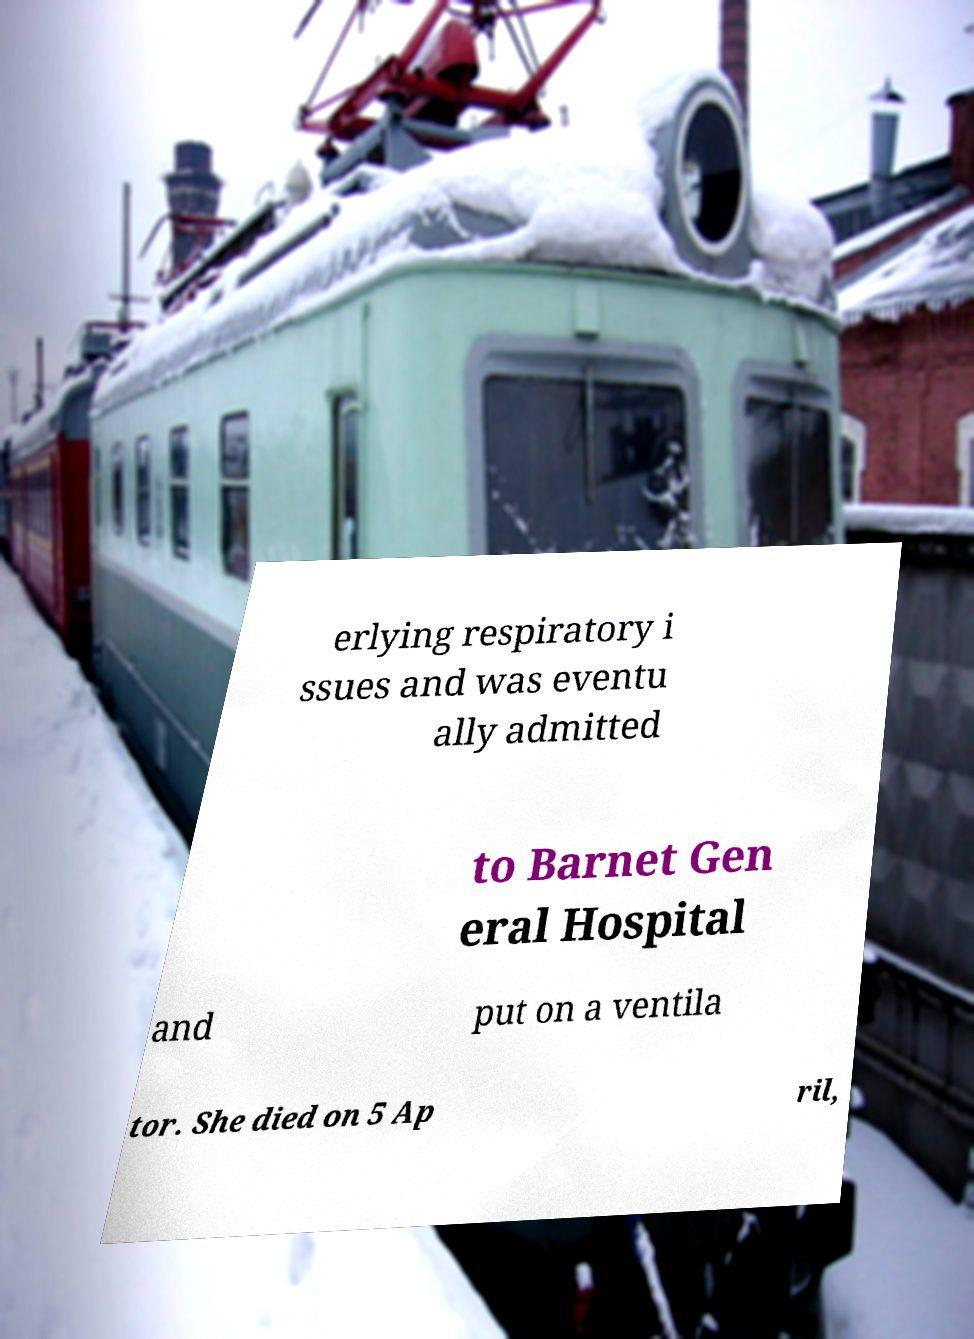Can you read and provide the text displayed in the image?This photo seems to have some interesting text. Can you extract and type it out for me? erlying respiratory i ssues and was eventu ally admitted to Barnet Gen eral Hospital and put on a ventila tor. She died on 5 Ap ril, 